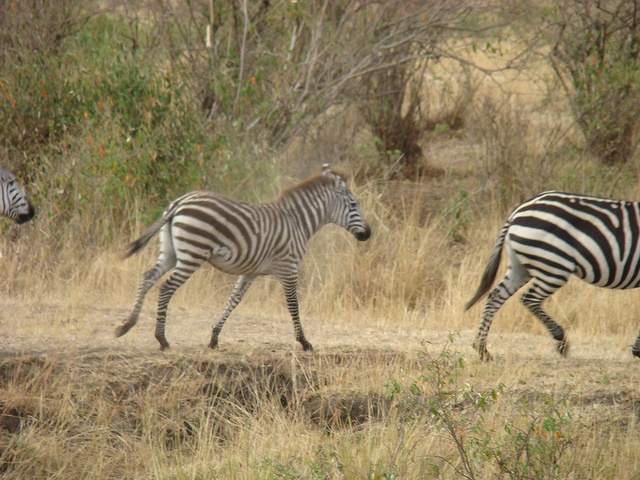Describe the objects in this image and their specific colors. I can see zebra in gray and darkgray tones, zebra in gray, black, darkgray, and tan tones, and zebra in gray, darkgray, and black tones in this image. 